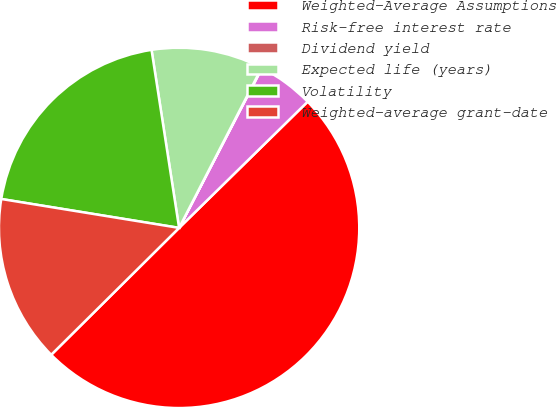<chart> <loc_0><loc_0><loc_500><loc_500><pie_chart><fcel>Weighted-Average Assumptions<fcel>Risk-free interest rate<fcel>Dividend yield<fcel>Expected life (years)<fcel>Volatility<fcel>Weighted-average grant-date<nl><fcel>49.91%<fcel>5.03%<fcel>0.04%<fcel>10.02%<fcel>19.99%<fcel>15.0%<nl></chart> 